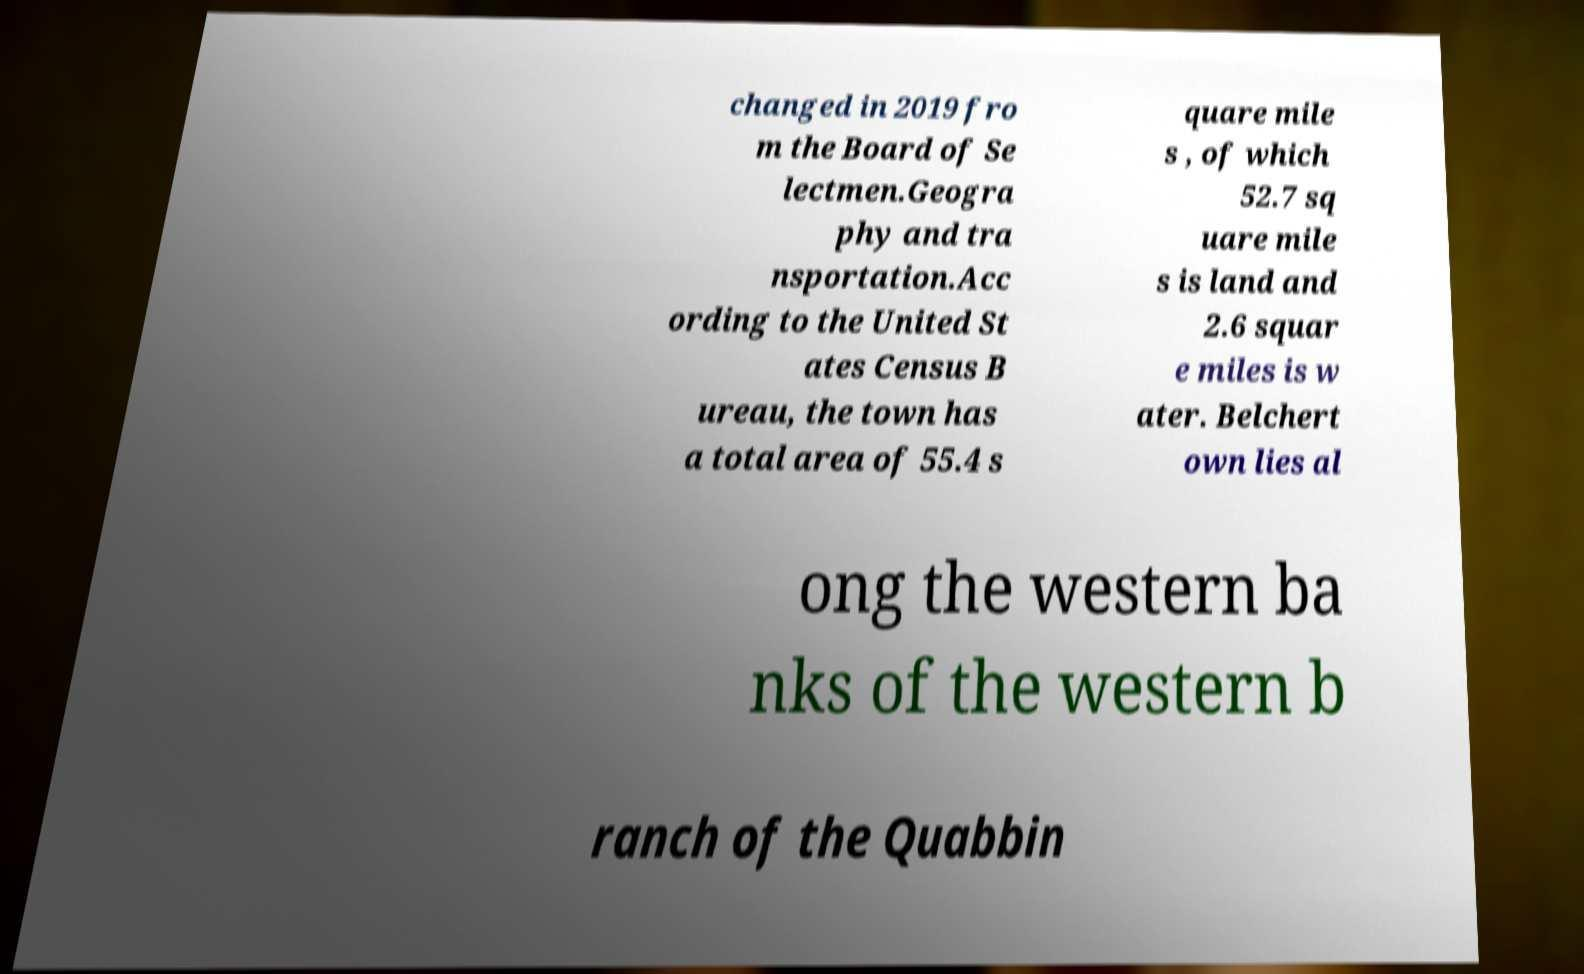For documentation purposes, I need the text within this image transcribed. Could you provide that? changed in 2019 fro m the Board of Se lectmen.Geogra phy and tra nsportation.Acc ording to the United St ates Census B ureau, the town has a total area of 55.4 s quare mile s , of which 52.7 sq uare mile s is land and 2.6 squar e miles is w ater. Belchert own lies al ong the western ba nks of the western b ranch of the Quabbin 